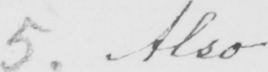Can you read and transcribe this handwriting? 5 . Also 